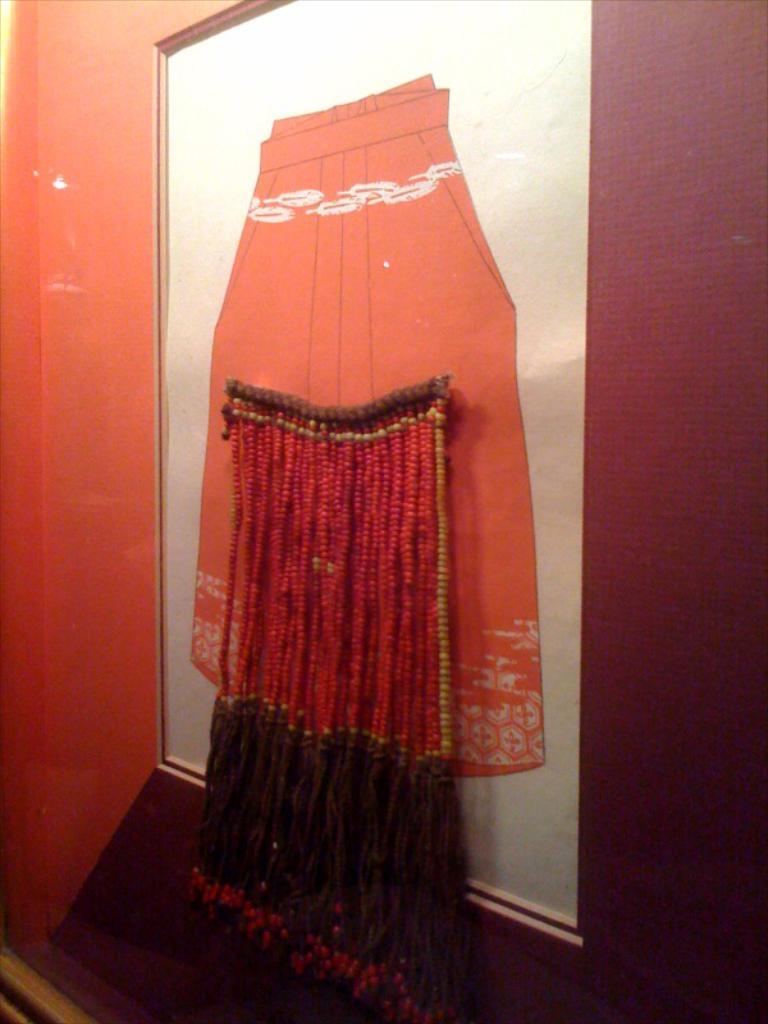Could you give a brief overview of what you see in this image? In this image, we can see a wall with a poster and some objects attached to it. 